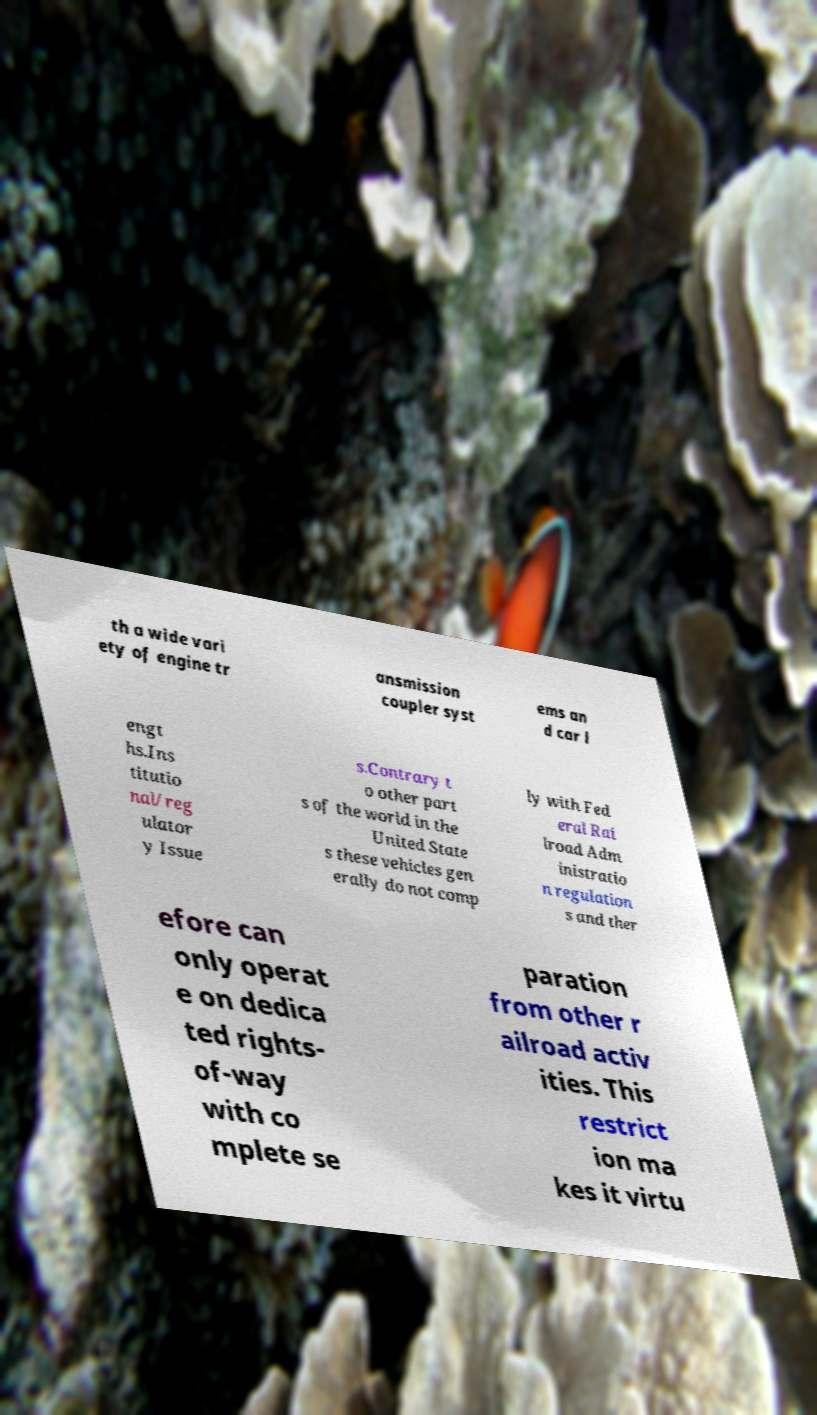Could you assist in decoding the text presented in this image and type it out clearly? th a wide vari ety of engine tr ansmission coupler syst ems an d car l engt hs.Ins titutio nal/reg ulator y Issue s.Contrary t o other part s of the world in the United State s these vehicles gen erally do not comp ly with Fed eral Rai lroad Adm inistratio n regulation s and ther efore can only operat e on dedica ted rights- of-way with co mplete se paration from other r ailroad activ ities. This restrict ion ma kes it virtu 